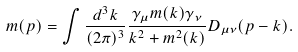Convert formula to latex. <formula><loc_0><loc_0><loc_500><loc_500>m ( p ) = \int \frac { d ^ { 3 } k } { ( 2 \pi ) ^ { 3 } } \frac { \gamma _ { \mu } m ( k ) \gamma _ { \nu } } { k ^ { 2 } + m ^ { 2 } ( k ) } D _ { \mu \nu } ( p - k ) .</formula> 